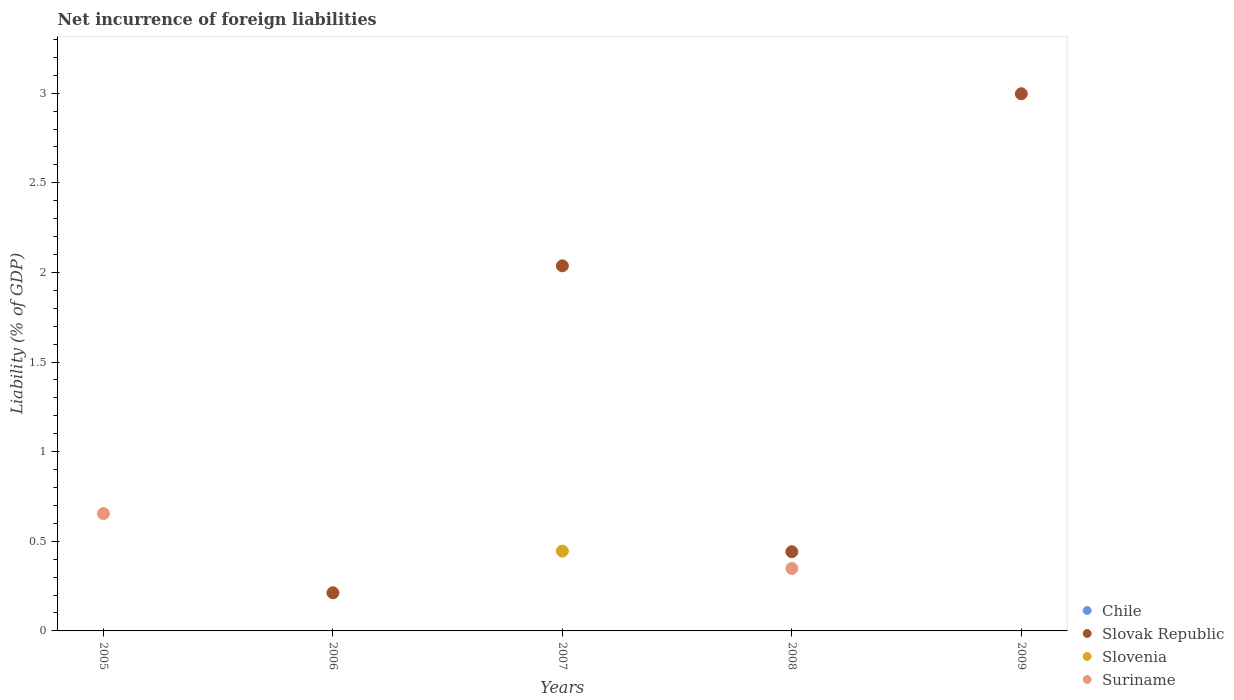How many different coloured dotlines are there?
Provide a short and direct response. 3. What is the net incurrence of foreign liabilities in Suriname in 2006?
Your answer should be compact. 0. Across all years, what is the maximum net incurrence of foreign liabilities in Slovak Republic?
Keep it short and to the point. 3. What is the difference between the net incurrence of foreign liabilities in Slovak Republic in 2007 and that in 2009?
Your answer should be compact. -0.96. What is the difference between the net incurrence of foreign liabilities in Slovenia in 2006 and the net incurrence of foreign liabilities in Slovak Republic in 2008?
Your answer should be very brief. -0.44. What is the average net incurrence of foreign liabilities in Slovenia per year?
Ensure brevity in your answer.  0.09. In the year 2008, what is the difference between the net incurrence of foreign liabilities in Suriname and net incurrence of foreign liabilities in Slovak Republic?
Your answer should be very brief. -0.09. What is the difference between the highest and the second highest net incurrence of foreign liabilities in Slovak Republic?
Your answer should be compact. 0.96. What is the difference between the highest and the lowest net incurrence of foreign liabilities in Slovenia?
Provide a short and direct response. 0.45. Is it the case that in every year, the sum of the net incurrence of foreign liabilities in Suriname and net incurrence of foreign liabilities in Slovenia  is greater than the net incurrence of foreign liabilities in Chile?
Your answer should be compact. No. Does the net incurrence of foreign liabilities in Chile monotonically increase over the years?
Offer a very short reply. No. Is the net incurrence of foreign liabilities in Suriname strictly greater than the net incurrence of foreign liabilities in Slovak Republic over the years?
Your answer should be compact. No. How many dotlines are there?
Your response must be concise. 3. Does the graph contain any zero values?
Make the answer very short. Yes. Does the graph contain grids?
Provide a succinct answer. No. What is the title of the graph?
Make the answer very short. Net incurrence of foreign liabilities. What is the label or title of the X-axis?
Your response must be concise. Years. What is the label or title of the Y-axis?
Your answer should be very brief. Liability (% of GDP). What is the Liability (% of GDP) of Slovenia in 2005?
Give a very brief answer. 0. What is the Liability (% of GDP) in Suriname in 2005?
Your answer should be compact. 0.65. What is the Liability (% of GDP) of Slovak Republic in 2006?
Offer a very short reply. 0.21. What is the Liability (% of GDP) in Slovenia in 2006?
Your answer should be compact. 0. What is the Liability (% of GDP) in Suriname in 2006?
Offer a terse response. 0. What is the Liability (% of GDP) of Slovak Republic in 2007?
Your answer should be compact. 2.04. What is the Liability (% of GDP) of Slovenia in 2007?
Provide a short and direct response. 0.45. What is the Liability (% of GDP) in Slovak Republic in 2008?
Ensure brevity in your answer.  0.44. What is the Liability (% of GDP) of Suriname in 2008?
Give a very brief answer. 0.35. What is the Liability (% of GDP) in Chile in 2009?
Your response must be concise. 0. What is the Liability (% of GDP) in Slovak Republic in 2009?
Keep it short and to the point. 3. Across all years, what is the maximum Liability (% of GDP) of Slovak Republic?
Make the answer very short. 3. Across all years, what is the maximum Liability (% of GDP) of Slovenia?
Your answer should be compact. 0.45. Across all years, what is the maximum Liability (% of GDP) of Suriname?
Give a very brief answer. 0.65. Across all years, what is the minimum Liability (% of GDP) in Slovak Republic?
Make the answer very short. 0. What is the total Liability (% of GDP) of Slovak Republic in the graph?
Keep it short and to the point. 5.69. What is the total Liability (% of GDP) in Slovenia in the graph?
Ensure brevity in your answer.  0.45. What is the difference between the Liability (% of GDP) of Suriname in 2005 and that in 2008?
Provide a succinct answer. 0.31. What is the difference between the Liability (% of GDP) of Slovak Republic in 2006 and that in 2007?
Ensure brevity in your answer.  -1.82. What is the difference between the Liability (% of GDP) of Slovak Republic in 2006 and that in 2008?
Make the answer very short. -0.23. What is the difference between the Liability (% of GDP) of Slovak Republic in 2006 and that in 2009?
Give a very brief answer. -2.78. What is the difference between the Liability (% of GDP) of Slovak Republic in 2007 and that in 2008?
Give a very brief answer. 1.6. What is the difference between the Liability (% of GDP) in Slovak Republic in 2007 and that in 2009?
Make the answer very short. -0.96. What is the difference between the Liability (% of GDP) of Slovak Republic in 2008 and that in 2009?
Offer a terse response. -2.56. What is the difference between the Liability (% of GDP) of Slovak Republic in 2006 and the Liability (% of GDP) of Slovenia in 2007?
Provide a short and direct response. -0.23. What is the difference between the Liability (% of GDP) of Slovak Republic in 2006 and the Liability (% of GDP) of Suriname in 2008?
Offer a terse response. -0.14. What is the difference between the Liability (% of GDP) of Slovak Republic in 2007 and the Liability (% of GDP) of Suriname in 2008?
Ensure brevity in your answer.  1.69. What is the difference between the Liability (% of GDP) of Slovenia in 2007 and the Liability (% of GDP) of Suriname in 2008?
Offer a very short reply. 0.1. What is the average Liability (% of GDP) in Chile per year?
Offer a very short reply. 0. What is the average Liability (% of GDP) in Slovak Republic per year?
Make the answer very short. 1.14. What is the average Liability (% of GDP) of Slovenia per year?
Keep it short and to the point. 0.09. What is the average Liability (% of GDP) of Suriname per year?
Offer a very short reply. 0.2. In the year 2007, what is the difference between the Liability (% of GDP) in Slovak Republic and Liability (% of GDP) in Slovenia?
Your response must be concise. 1.59. In the year 2008, what is the difference between the Liability (% of GDP) in Slovak Republic and Liability (% of GDP) in Suriname?
Provide a succinct answer. 0.09. What is the ratio of the Liability (% of GDP) in Suriname in 2005 to that in 2008?
Your response must be concise. 1.88. What is the ratio of the Liability (% of GDP) of Slovak Republic in 2006 to that in 2007?
Ensure brevity in your answer.  0.1. What is the ratio of the Liability (% of GDP) of Slovak Republic in 2006 to that in 2008?
Ensure brevity in your answer.  0.48. What is the ratio of the Liability (% of GDP) of Slovak Republic in 2006 to that in 2009?
Offer a terse response. 0.07. What is the ratio of the Liability (% of GDP) of Slovak Republic in 2007 to that in 2008?
Make the answer very short. 4.61. What is the ratio of the Liability (% of GDP) of Slovak Republic in 2007 to that in 2009?
Your answer should be very brief. 0.68. What is the ratio of the Liability (% of GDP) of Slovak Republic in 2008 to that in 2009?
Your answer should be compact. 0.15. What is the difference between the highest and the second highest Liability (% of GDP) of Slovak Republic?
Ensure brevity in your answer.  0.96. What is the difference between the highest and the lowest Liability (% of GDP) of Slovak Republic?
Keep it short and to the point. 3. What is the difference between the highest and the lowest Liability (% of GDP) of Slovenia?
Offer a terse response. 0.45. What is the difference between the highest and the lowest Liability (% of GDP) in Suriname?
Offer a very short reply. 0.65. 